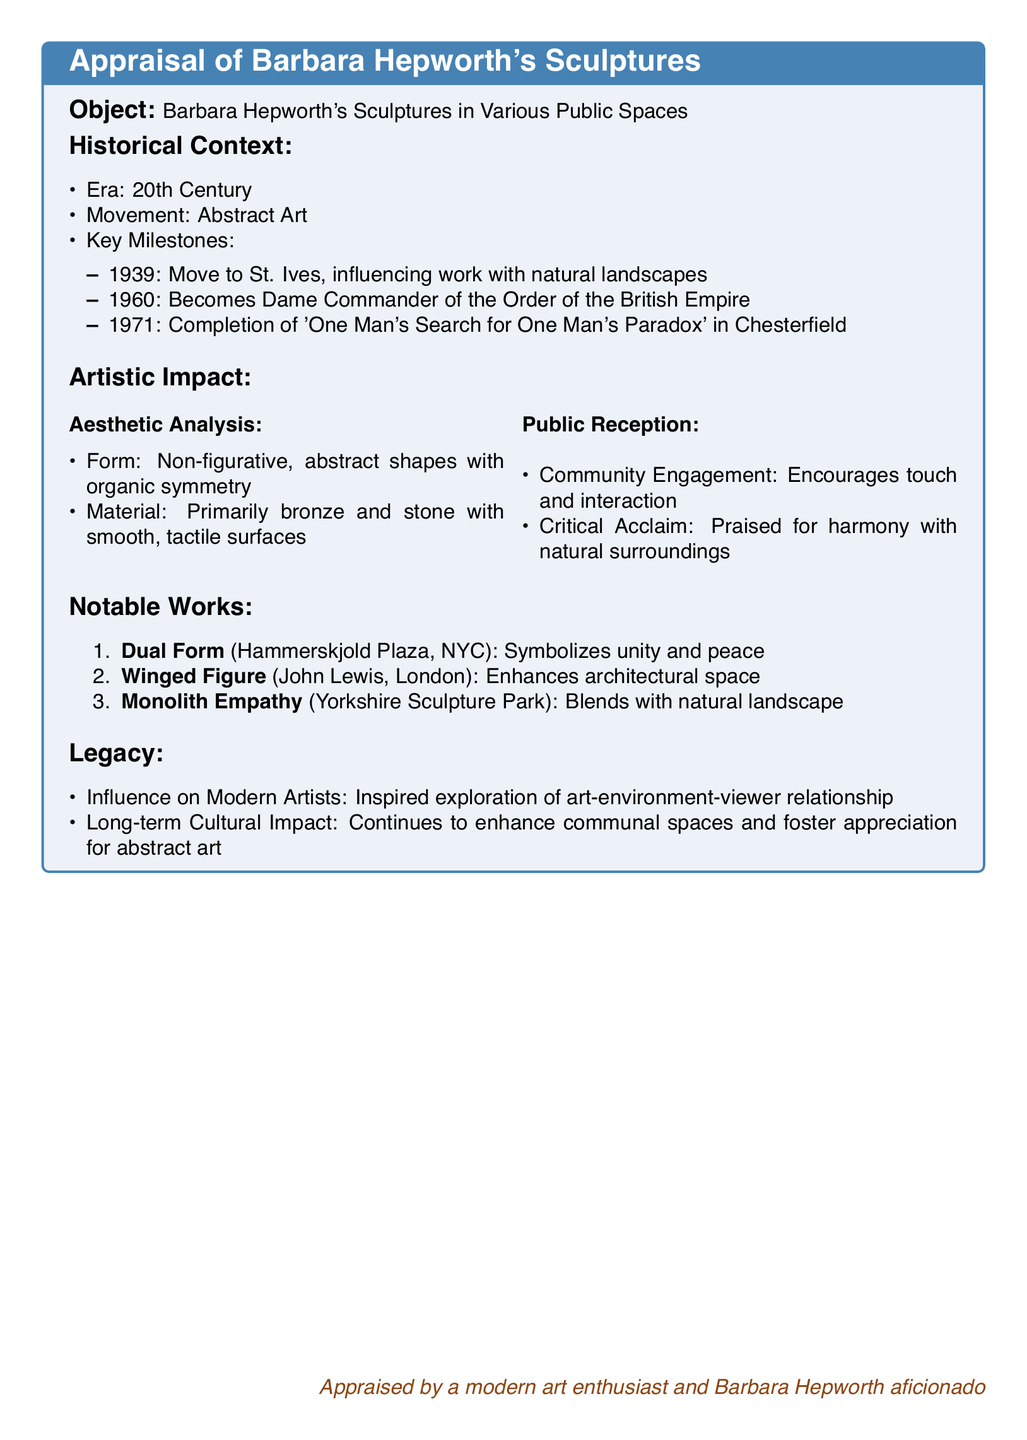What year did Barbara Hepworth become a Dame Commander? The document states that she was honored with this title in 1960.
Answer: 1960 What is the material primarily used in Hepworth's sculptures? According to the appraisal, the sculptures are primarily made of bronze and stone.
Answer: bronze and stone Name one notable work by Hepworth located in New York City. The document lists "Dual Form" as a notable work in Hammerskjold Plaza, NYC.
Answer: Dual Form How does Hepworth's art encourage community engagement? The appraisal mentions that her works encourage touch and interaction, fostering community connection.
Answer: touch and interaction What movement is Barbara Hepworth associated with? The historical context identifies Hepworth's association with the Abstract Art movement.
Answer: Abstract Art How did the public receive Hepworth's work according to the document? The appraisal states that her sculptures were praised for their harmony with natural surroundings, indicating positive public reception.
Answer: harmony with natural surroundings Which notable work is mentioned in connection with the Yorkshire Sculpture Park? The document identifies "Monolith Empathy" as the notable work located there.
Answer: Monolith Empathy What key milestone occurred in 1971 for Hepworth? The document notes the completion of 'One Man's Search for One Man's Paradox' as a key milestone in that year.
Answer: Completion of 'One Man's Search for One Man's Paradox' What influence did Hepworth have on modern artists? The appraisal explains that she inspired exploration of the art-environment-viewer relationship among modern artists.
Answer: exploration of art-environment-viewer relationship 